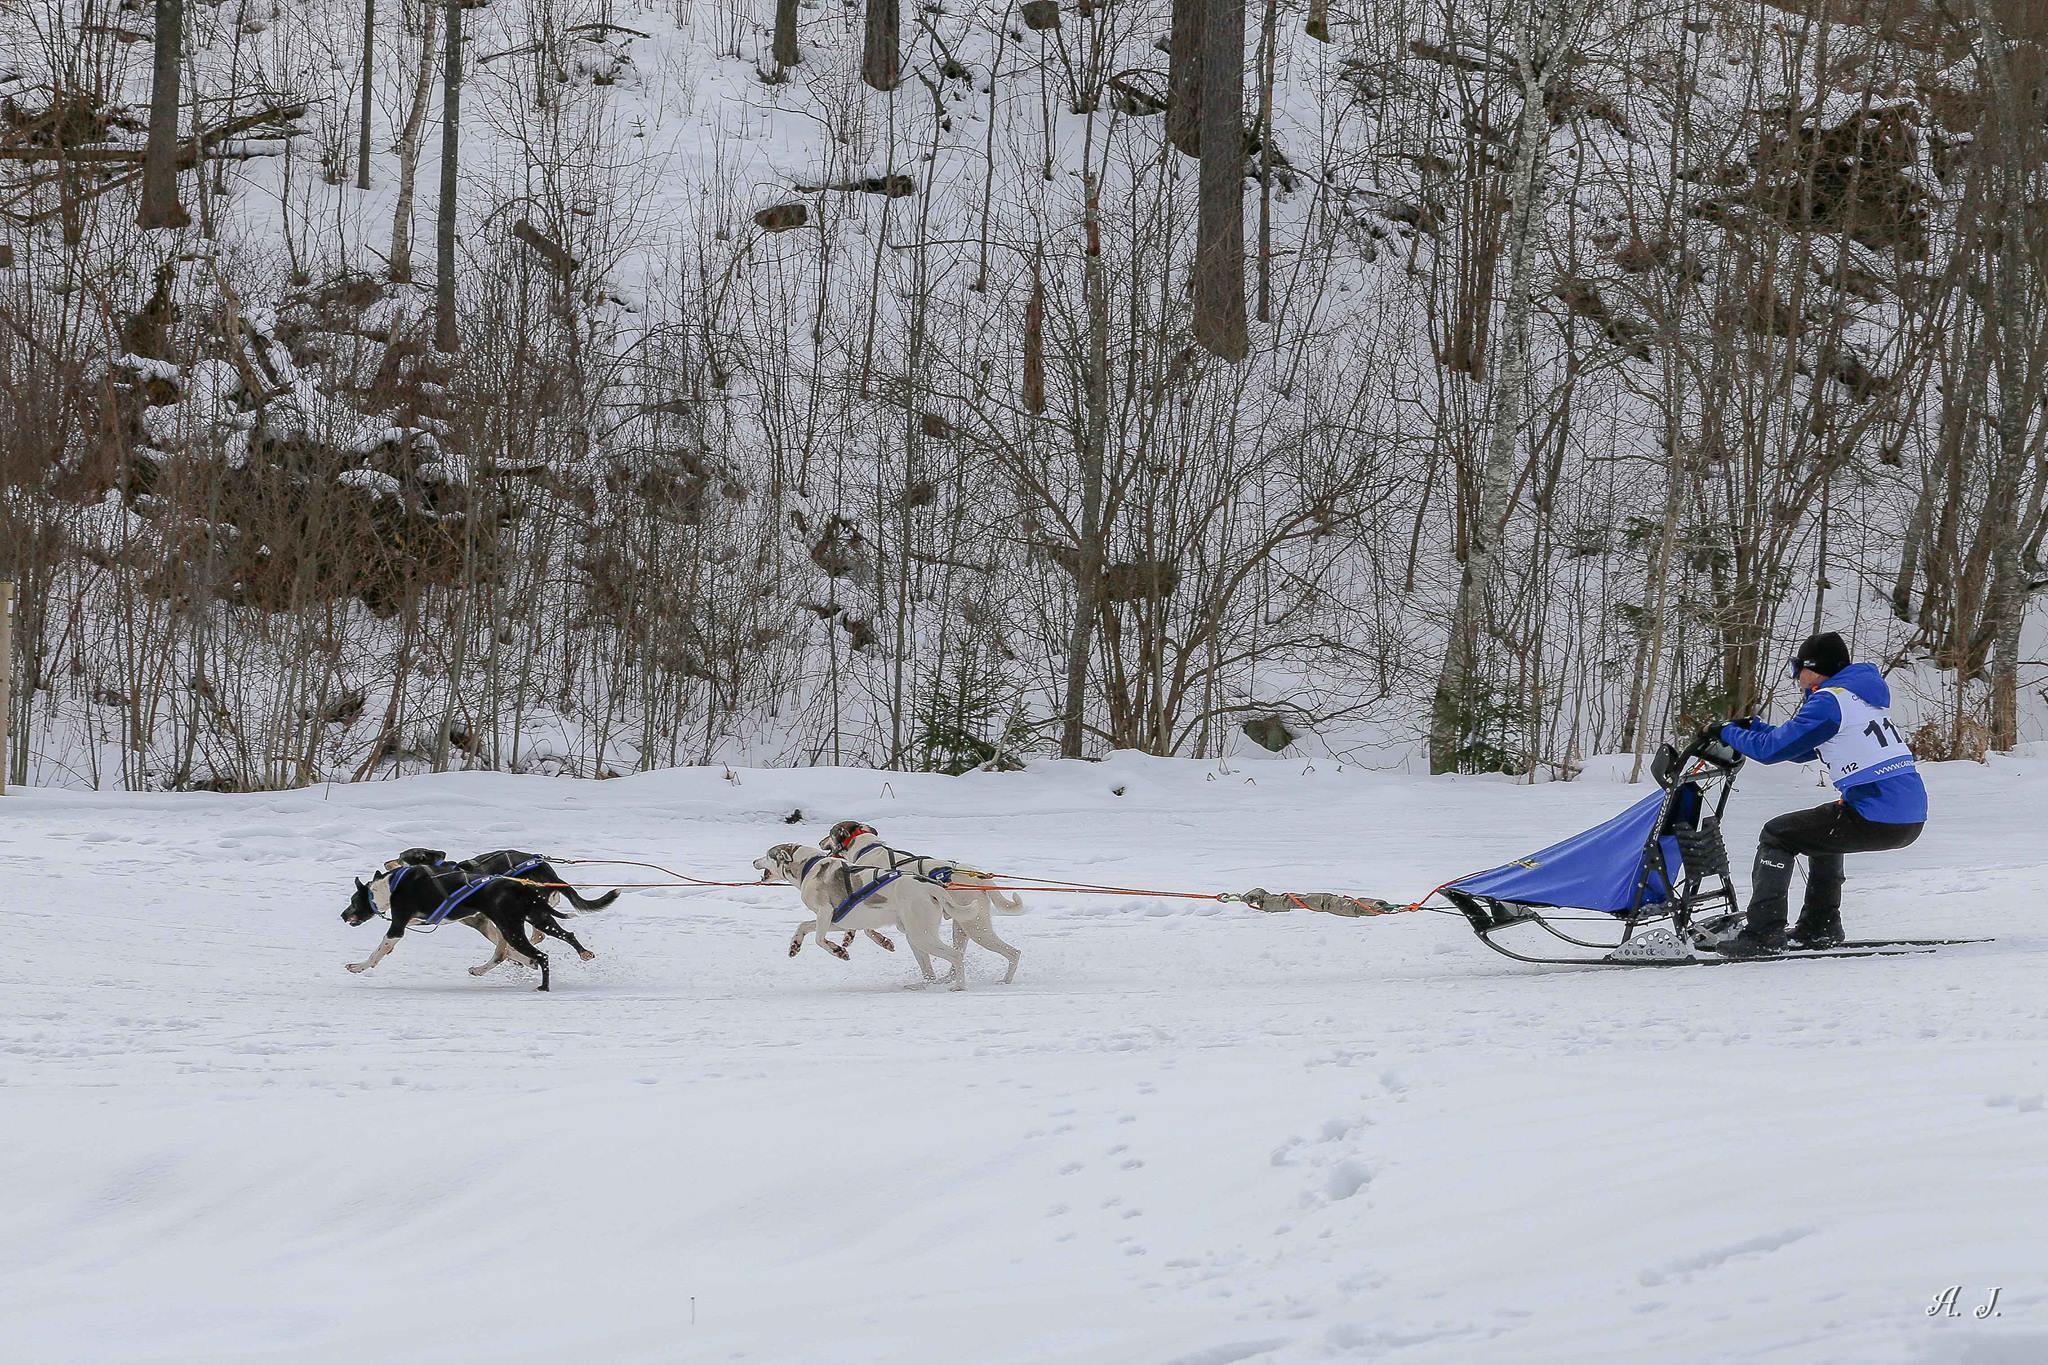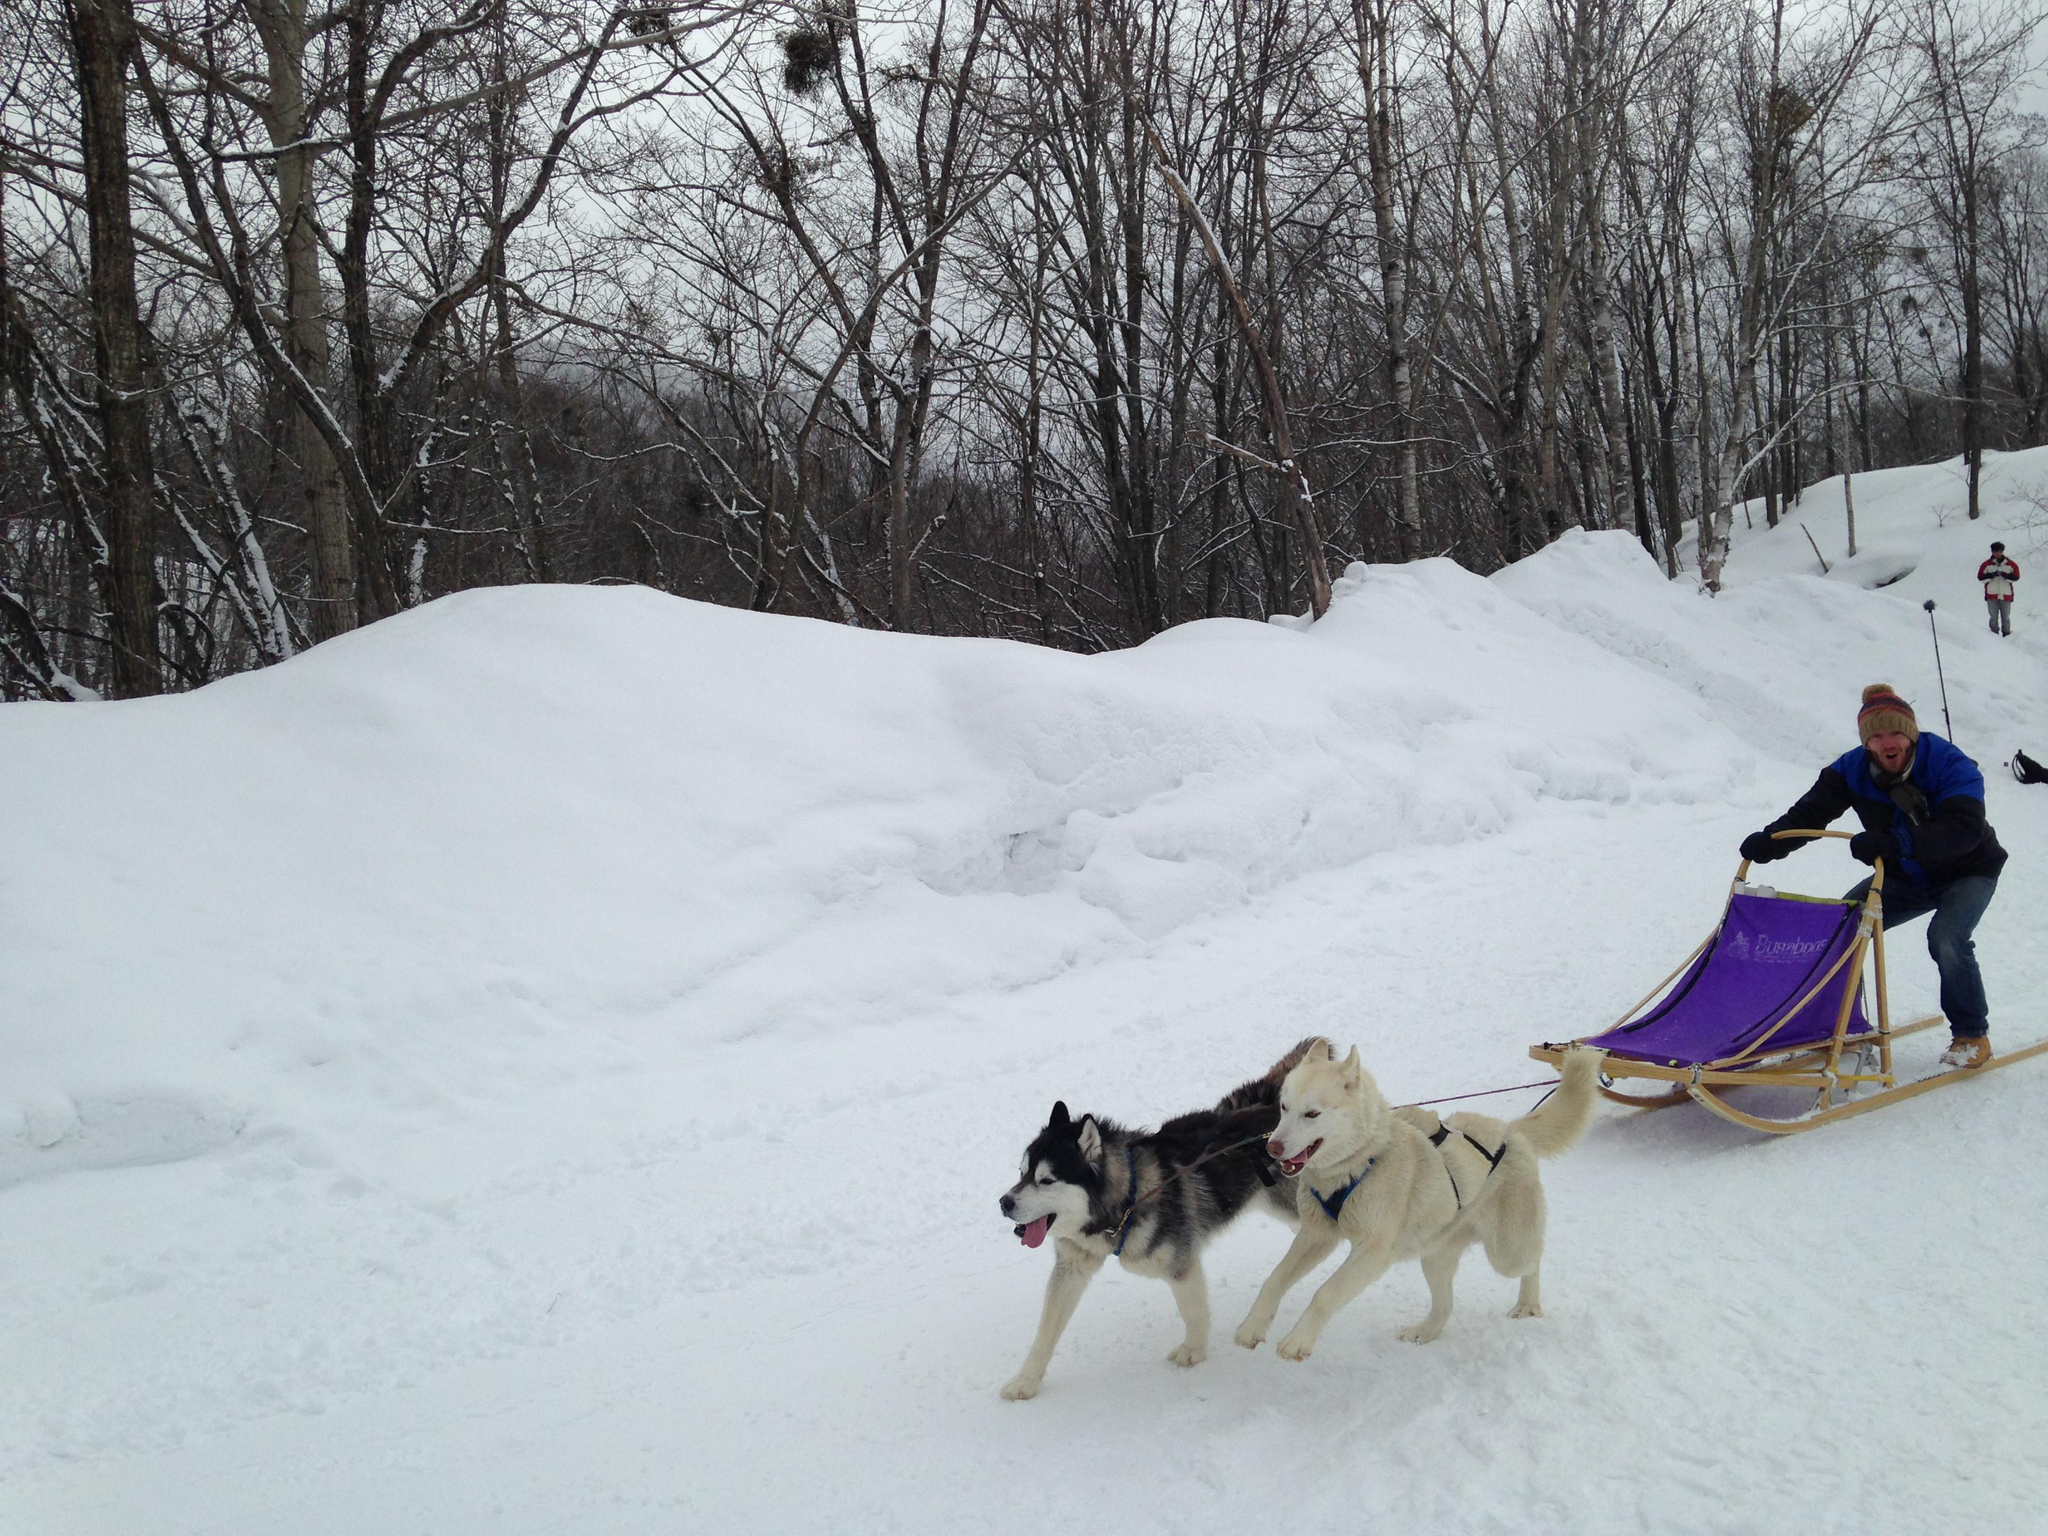The first image is the image on the left, the second image is the image on the right. Given the left and right images, does the statement "An image shows a sled driver standing behind an empty sled, and only two visible dogs pulling it." hold true? Answer yes or no. Yes. The first image is the image on the left, the second image is the image on the right. Assess this claim about the two images: "All the sleds are pointing to the left.". Correct or not? Answer yes or no. Yes. 